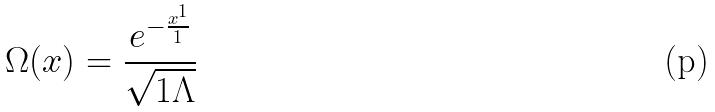Convert formula to latex. <formula><loc_0><loc_0><loc_500><loc_500>\Omega ( x ) = \frac { e ^ { - \frac { x ^ { 1 } } { 1 } } } { \sqrt { 1 \Lambda } }</formula> 